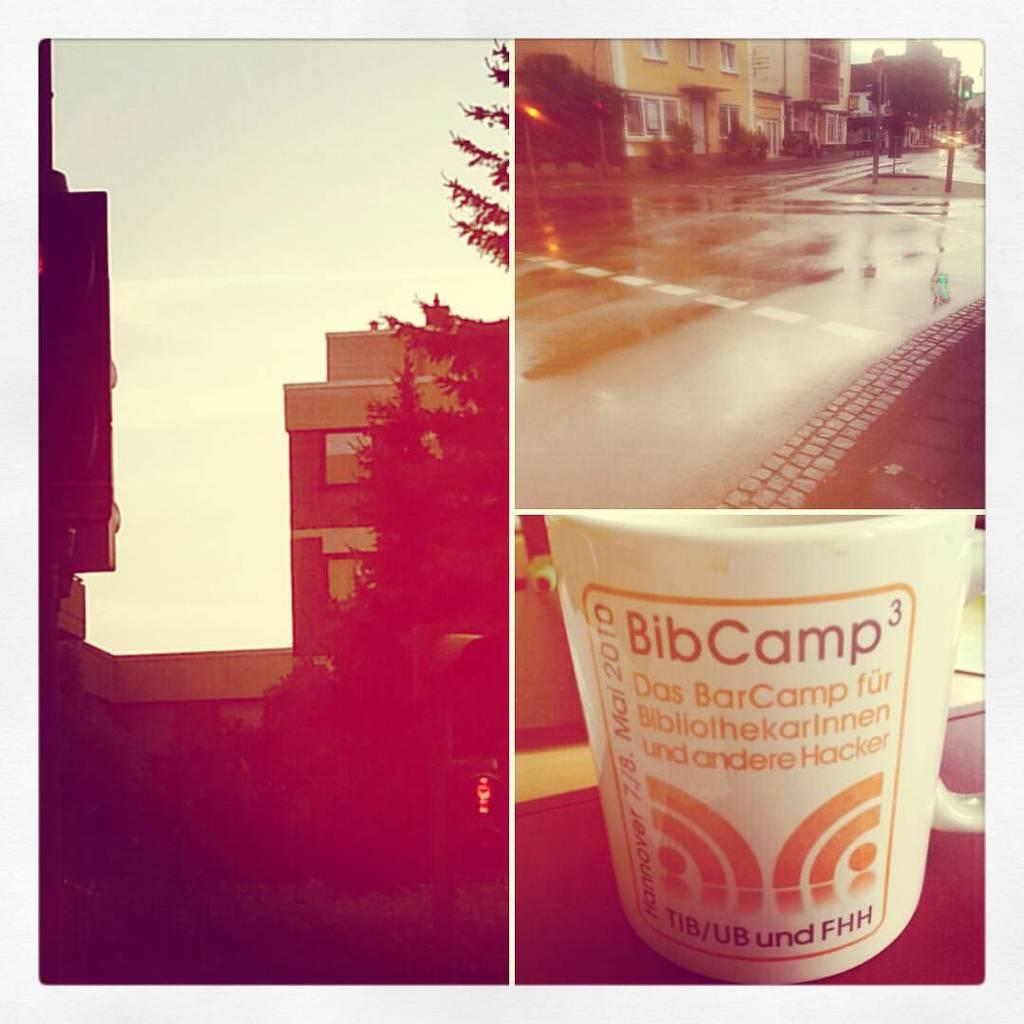<image>
Summarize the visual content of the image. Montage of photos with BibCamp cup showing on the bottom. 